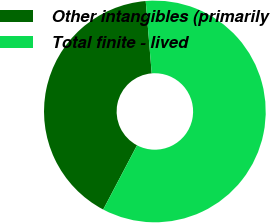<chart> <loc_0><loc_0><loc_500><loc_500><pie_chart><fcel>Other intangibles (primarily<fcel>Total finite - lived<nl><fcel>40.97%<fcel>59.03%<nl></chart> 